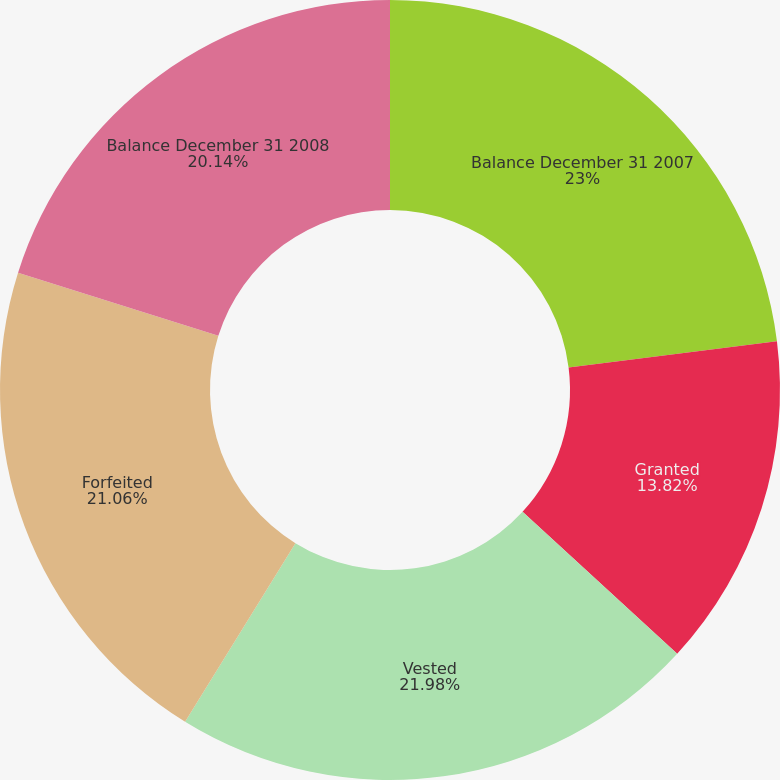Convert chart to OTSL. <chart><loc_0><loc_0><loc_500><loc_500><pie_chart><fcel>Balance December 31 2007<fcel>Granted<fcel>Vested<fcel>Forfeited<fcel>Balance December 31 2008<nl><fcel>23.01%<fcel>13.82%<fcel>21.98%<fcel>21.06%<fcel>20.14%<nl></chart> 